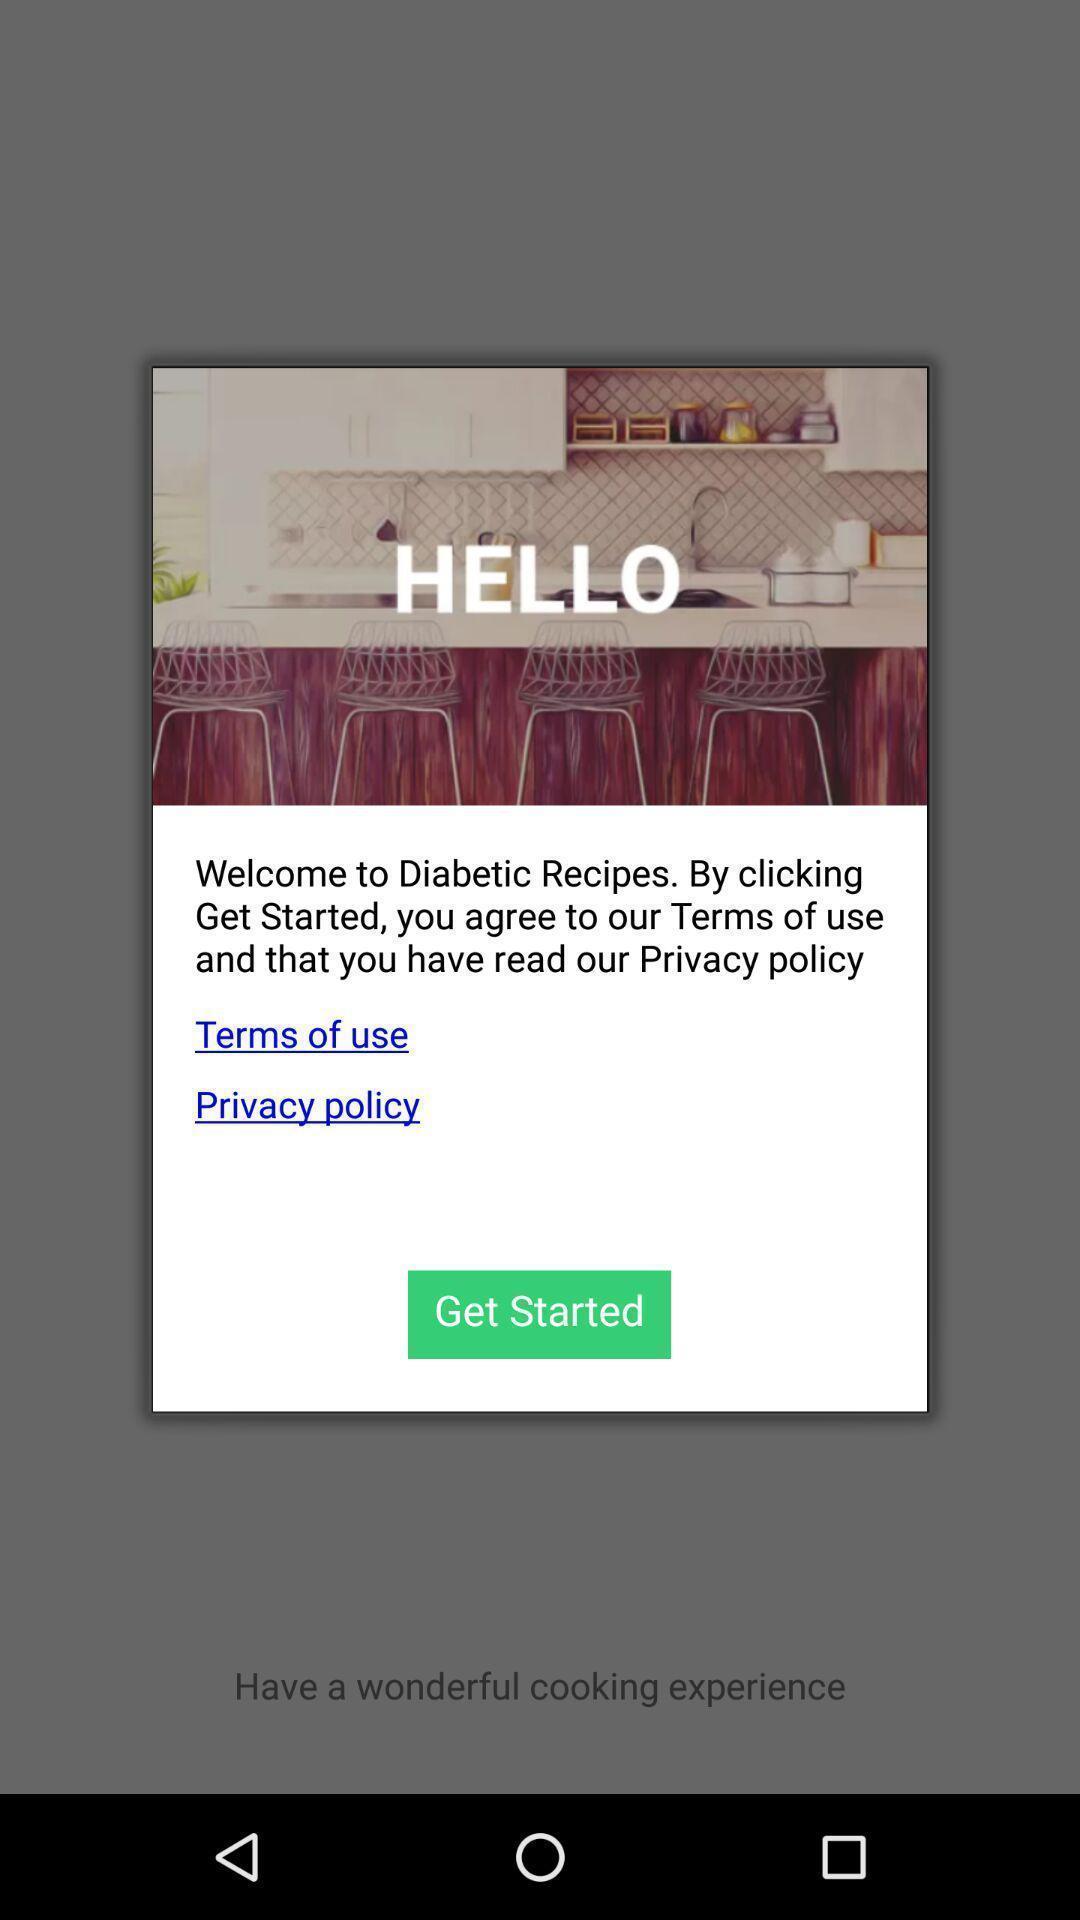Explain the elements present in this screenshot. Pop-up asking permission to get started. 